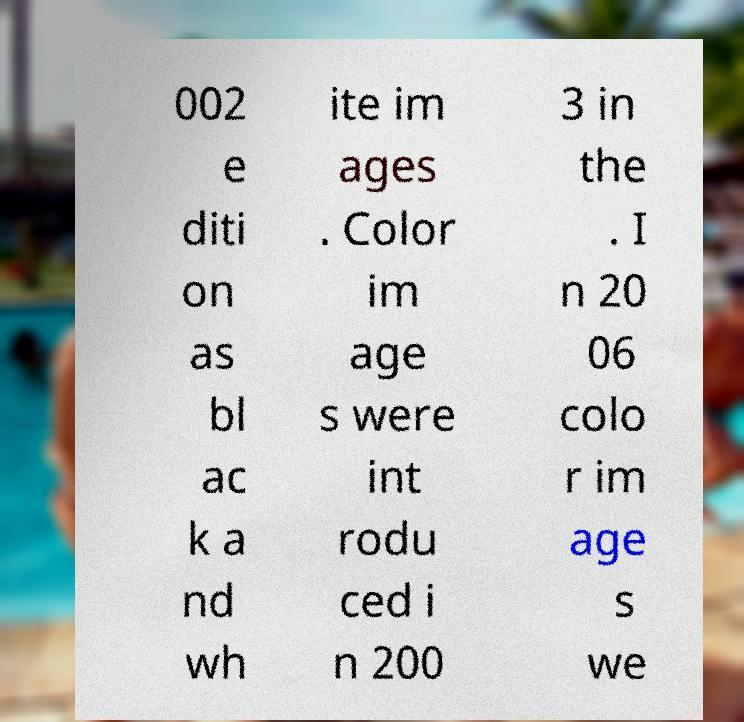Can you read and provide the text displayed in the image?This photo seems to have some interesting text. Can you extract and type it out for me? 002 e diti on as bl ac k a nd wh ite im ages . Color im age s were int rodu ced i n 200 3 in the . I n 20 06 colo r im age s we 